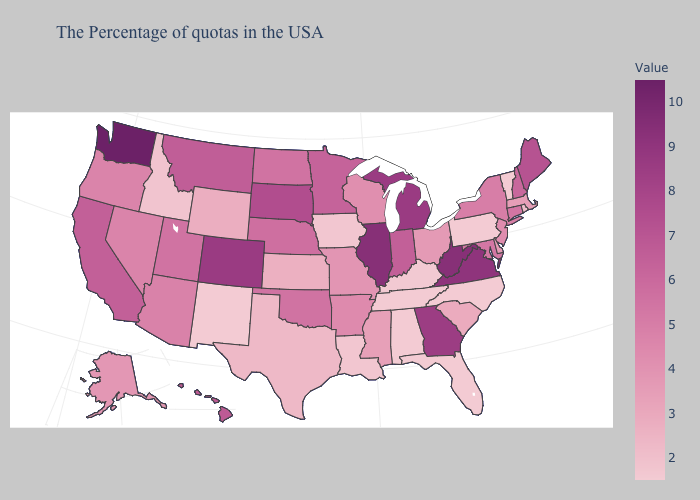Does Vermont have the lowest value in the USA?
Keep it brief. Yes. Does Maryland have a higher value than Minnesota?
Answer briefly. No. Does Hawaii have a higher value than West Virginia?
Short answer required. No. Among the states that border Iowa , which have the highest value?
Be succinct. Illinois. Among the states that border California , which have the lowest value?
Answer briefly. Nevada, Oregon. Does the map have missing data?
Keep it brief. No. Does Nebraska have a higher value than Florida?
Write a very short answer. Yes. 